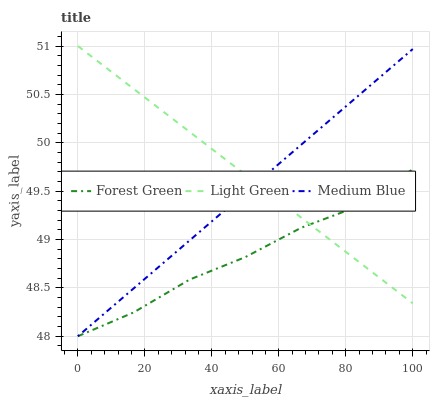Does Medium Blue have the minimum area under the curve?
Answer yes or no. No. Does Medium Blue have the maximum area under the curve?
Answer yes or no. No. Is Medium Blue the smoothest?
Answer yes or no. No. Is Medium Blue the roughest?
Answer yes or no. No. Does Light Green have the lowest value?
Answer yes or no. No. Does Medium Blue have the highest value?
Answer yes or no. No. 